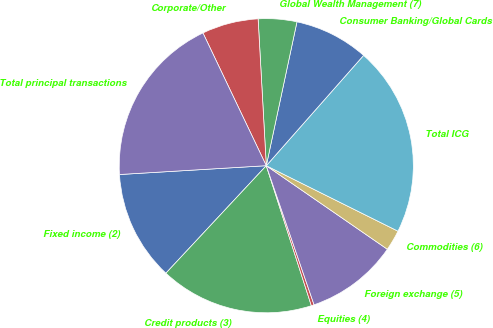Convert chart to OTSL. <chart><loc_0><loc_0><loc_500><loc_500><pie_chart><fcel>Fixed income (2)<fcel>Credit products (3)<fcel>Equities (4)<fcel>Foreign exchange (5)<fcel>Commodities (6)<fcel>Total ICG<fcel>Consumer Banking/Global Cards<fcel>Global Wealth Management (7)<fcel>Corporate/Other<fcel>Total principal transactions<nl><fcel>12.09%<fcel>16.91%<fcel>0.31%<fcel>10.12%<fcel>2.27%<fcel>20.84%<fcel>8.16%<fcel>4.23%<fcel>6.2%<fcel>18.87%<nl></chart> 